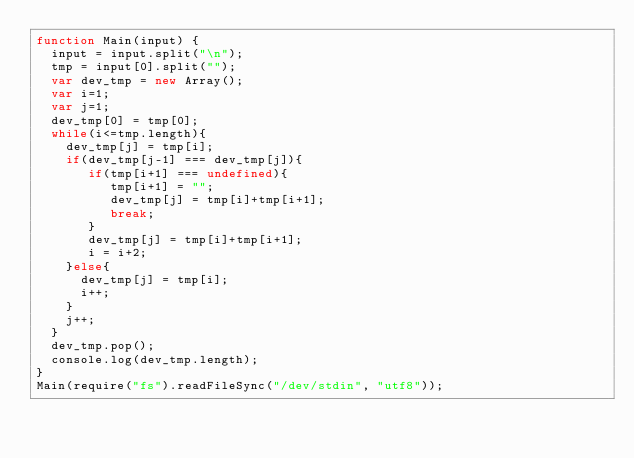<code> <loc_0><loc_0><loc_500><loc_500><_JavaScript_>function Main(input) {
	input = input.split("\n");
	tmp = input[0].split("");
	var dev_tmp = new Array();
	var i=1;
	var j=1;
	dev_tmp[0] = tmp[0];
  while(i<=tmp.length){
    dev_tmp[j] = tmp[i];
    if(dev_tmp[j-1] === dev_tmp[j]){
       if(tmp[i+1] === undefined){
          tmp[i+1] = "";
          dev_tmp[j] = tmp[i]+tmp[i+1];
          break;
       }
       dev_tmp[j] = tmp[i]+tmp[i+1];
       i = i+2;
    }else{       
      dev_tmp[j] = tmp[i];
      i++;
    }
    j++;
  }
  dev_tmp.pop();
  console.log(dev_tmp.length);
}
Main(require("fs").readFileSync("/dev/stdin", "utf8"));</code> 